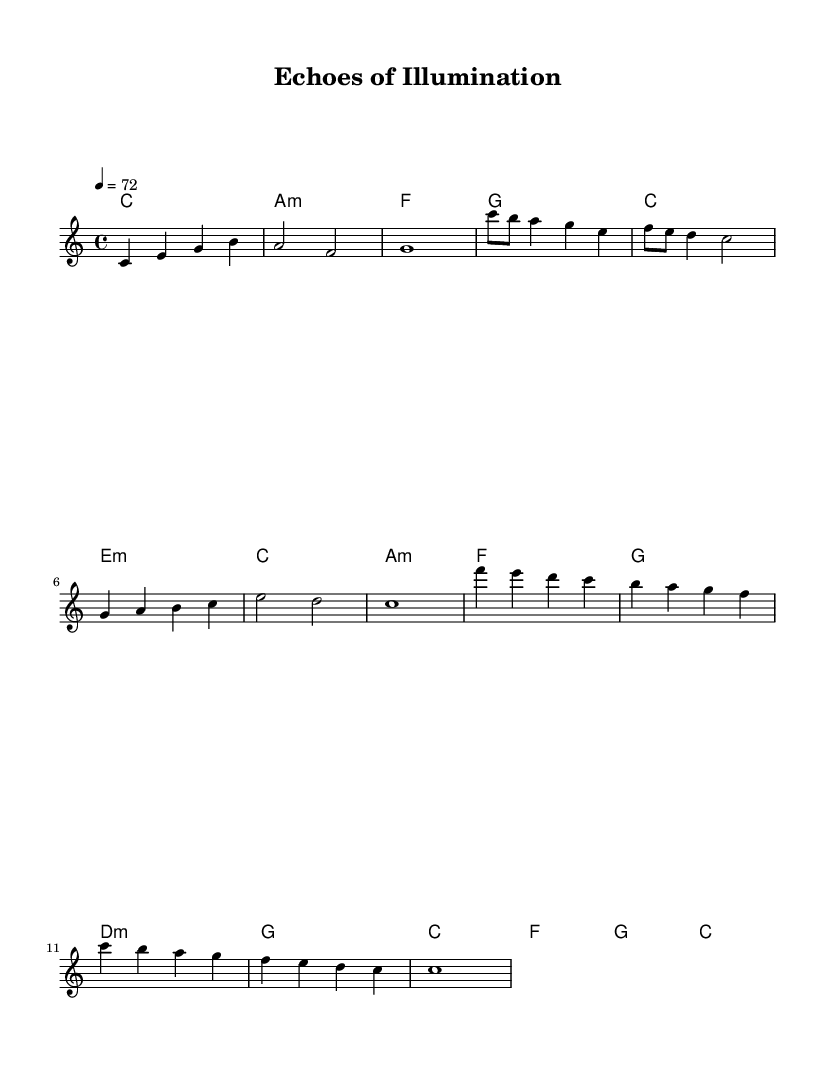What is the time signature of this music? The time signature is found at the beginning of the music sheet, written as 4/4. This indicates that there are four beats in each measure.
Answer: 4/4 What is the key signature of this music? The key signature is indicated at the beginning of the score. In this case, there are no sharps or flats, indicating that the piece is in C major.
Answer: C major What is the tempo marking for the music? The tempo marking is located in the header section of the sheet music and reads "4 = 72." This means that the quarter note gets 72 beats per minute.
Answer: 72 How many measures are in the chorus section? To determine the number of measures in the chorus, we look at the highlighted section labeled as the chorus, counting the measures present. There are 4 measures in this section.
Answer: 4 Which chord is played during the bridge section? The bridge section corresponds to the harmonies indicated, where the chords are D minor and G major. The specific chord in the first part of the bridge is D minor, followed by G major.
Answer: D minor What is the final note of the melody? The last note can be found at the end of the melody in the outro section. It is indicated as a whole note "c" which signifies the final chord and note of the piece.
Answer: c How many unique chords are used in the music? By reviewing the chord progression throughout the music, we identify the unique chords played: C, A minor, F, G, E minor, and D minor. Counting these gives us a total of 6 unique chords.
Answer: 6 